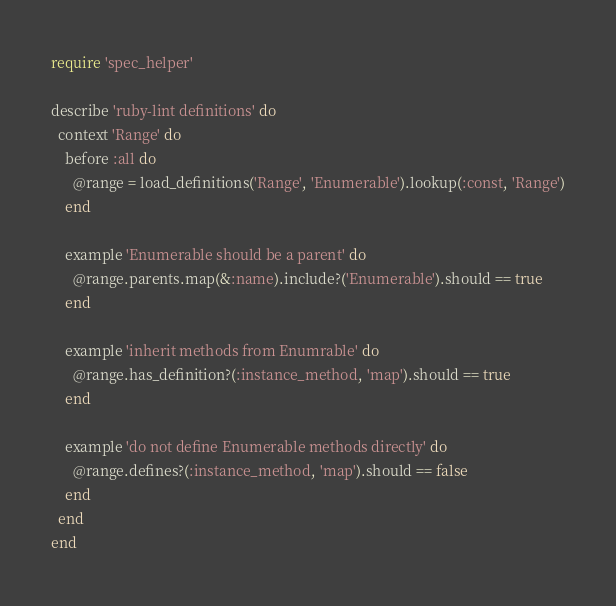Convert code to text. <code><loc_0><loc_0><loc_500><loc_500><_Ruby_>require 'spec_helper'

describe 'ruby-lint definitions' do
  context 'Range' do
    before :all do
      @range = load_definitions('Range', 'Enumerable').lookup(:const, 'Range')
    end

    example 'Enumerable should be a parent' do
      @range.parents.map(&:name).include?('Enumerable').should == true
    end

    example 'inherit methods from Enumrable' do
      @range.has_definition?(:instance_method, 'map').should == true
    end

    example 'do not define Enumerable methods directly' do
      @range.defines?(:instance_method, 'map').should == false
    end
  end
end
</code> 